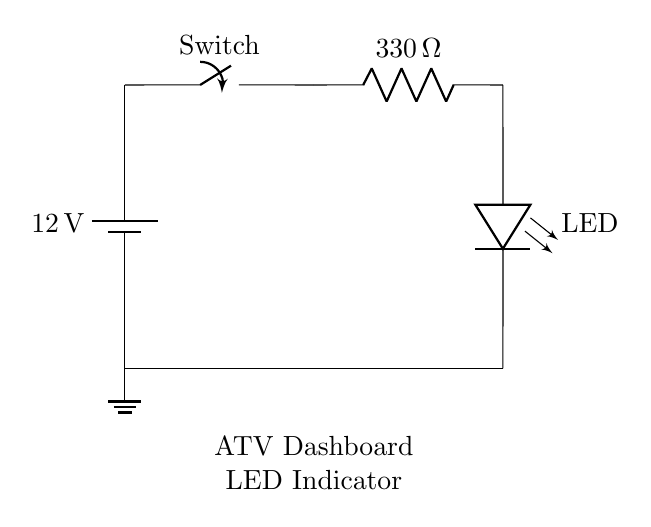What is the voltage of the battery? The circuit shows a battery labeled with twelve volts, indicating it supplies that voltage.
Answer: 12 volts What is the resistance value in the circuit? The resistor in the circuit is labeled as three hundred thirty ohms, which is the resistance it provides.
Answer: 330 ohms What component provides visual indication on the ATV dashboard? The LED, or light-emitting diode, is specified in the circuit as the visual indicator component.
Answer: LED How many open switches are in this circuit? The circuit contains one switch, which is depicted in the diagram as the only switch component present.
Answer: One What is the role of the resistor in this LED circuit? The resistor limits the amount of current flowing through the LED, preventing it from being damaged by excess current.
Answer: Current limiter If the switch is closed, what happens to the LED? When the switch is closed, it completes the circuit allowing current to flow, which turns the LED on, illuminating it.
Answer: LED turns on What is the connection type from the LED to ground? The LED is connected to ground through a direct short, completing the circuit and providing a return path for current.
Answer: Short connection 